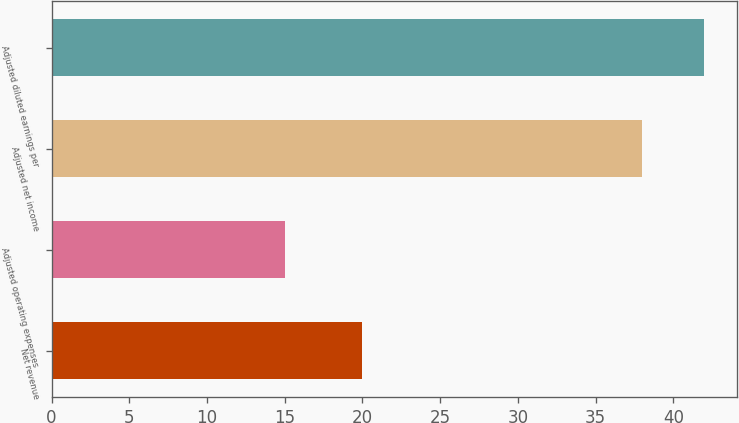<chart> <loc_0><loc_0><loc_500><loc_500><bar_chart><fcel>Net revenue<fcel>Adjusted operating expenses<fcel>Adjusted net income<fcel>Adjusted diluted earnings per<nl><fcel>20<fcel>15<fcel>38<fcel>42<nl></chart> 